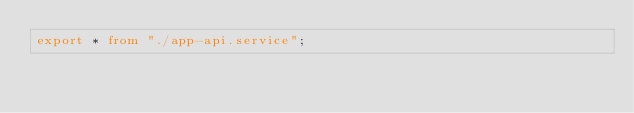<code> <loc_0><loc_0><loc_500><loc_500><_TypeScript_>export * from "./app-api.service";
</code> 